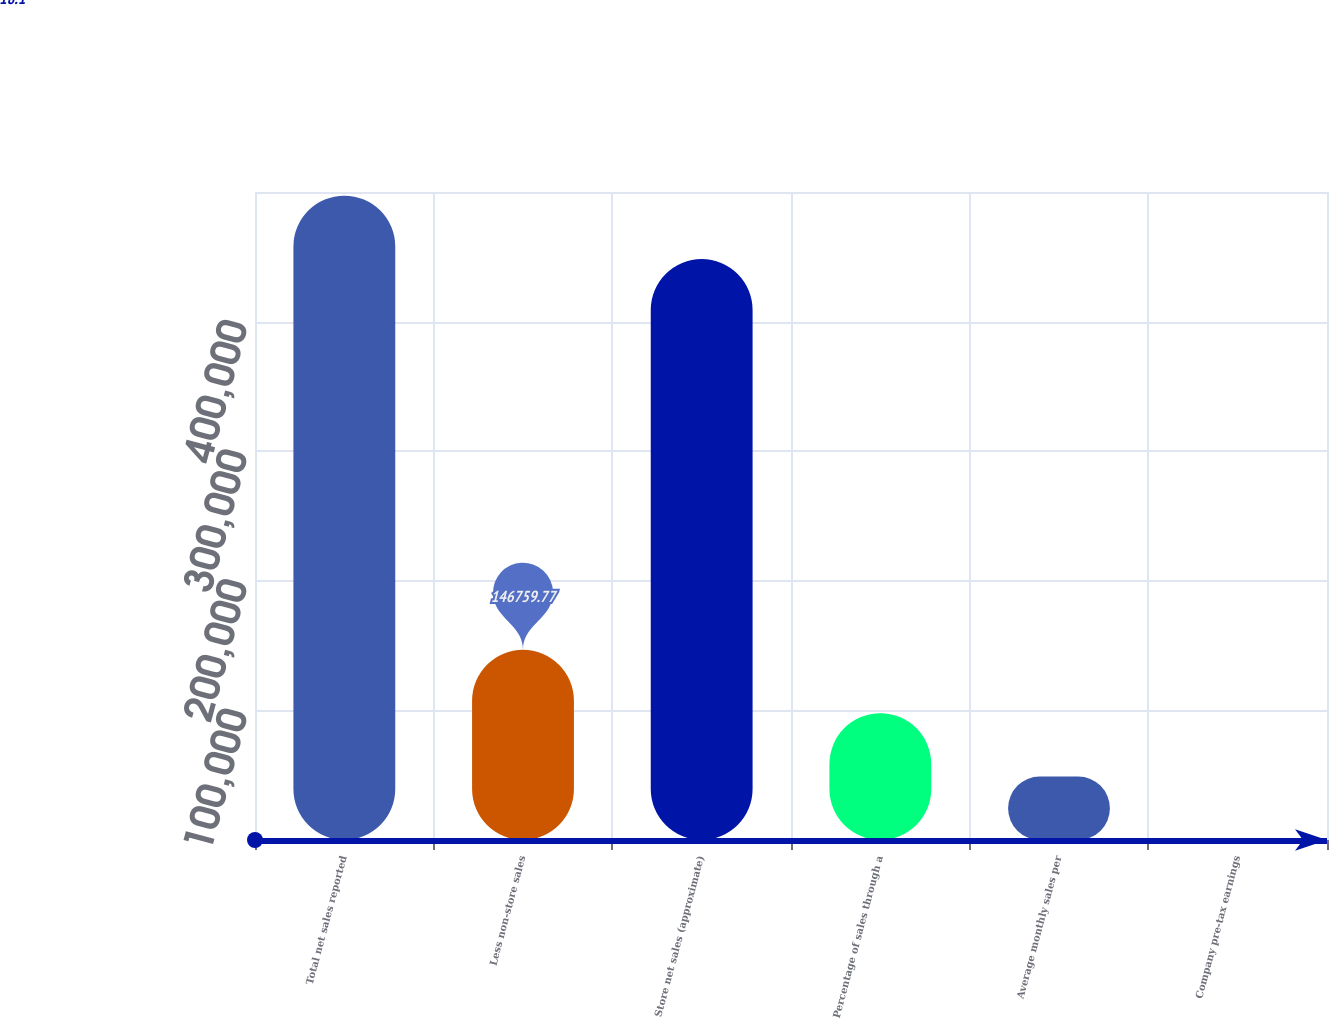<chart> <loc_0><loc_0><loc_500><loc_500><bar_chart><fcel>Total net sales reported<fcel>Less non-store sales<fcel>Store net sales (approximate)<fcel>Percentage of sales through a<fcel>Average monthly sales per<fcel>Company pre-tax earnings<nl><fcel>497180<fcel>146760<fcel>448266<fcel>97845.9<fcel>48932<fcel>18.1<nl></chart> 